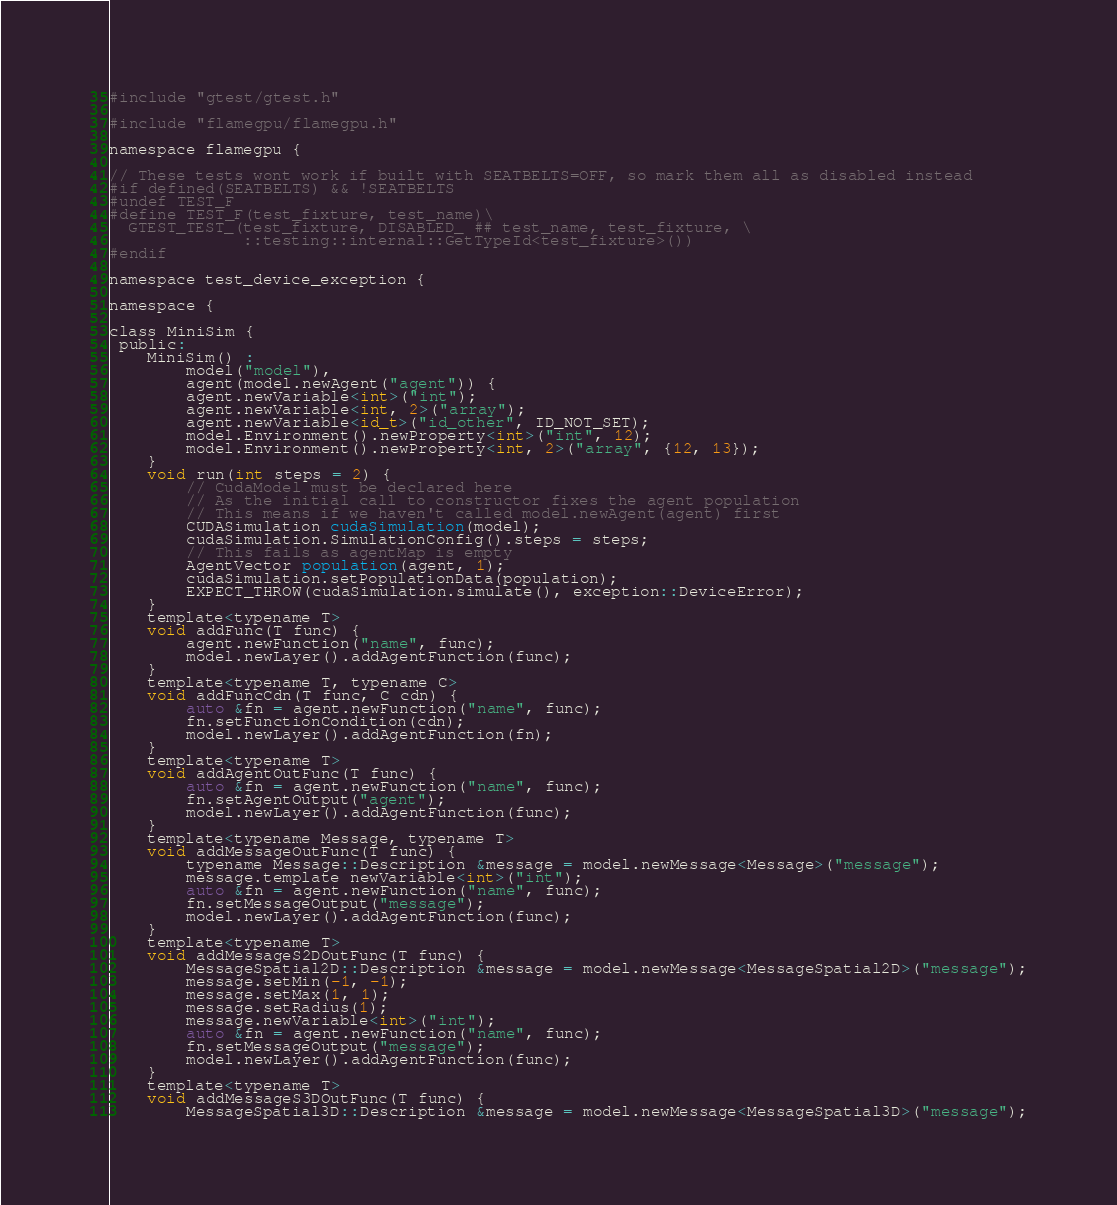Convert code to text. <code><loc_0><loc_0><loc_500><loc_500><_Cuda_>
#include "gtest/gtest.h"

#include "flamegpu/flamegpu.h"

namespace flamegpu {

// These tests wont work if built with SEATBELTS=OFF, so mark them all as disabled instead
#if defined(SEATBELTS) && !SEATBELTS
#undef TEST_F
#define TEST_F(test_fixture, test_name)\
  GTEST_TEST_(test_fixture, DISABLED_ ## test_name, test_fixture, \
              ::testing::internal::GetTypeId<test_fixture>())
#endif

namespace test_device_exception {

namespace {

class MiniSim {
 public:
    MiniSim() :
        model("model"),
        agent(model.newAgent("agent")) {
        agent.newVariable<int>("int");
        agent.newVariable<int, 2>("array");
        agent.newVariable<id_t>("id_other", ID_NOT_SET);
        model.Environment().newProperty<int>("int", 12);
        model.Environment().newProperty<int, 2>("array", {12, 13});
    }
    void run(int steps = 2) {
        // CudaModel must be declared here
        // As the initial call to constructor fixes the agent population
        // This means if we haven't called model.newAgent(agent) first
        CUDASimulation cudaSimulation(model);
        cudaSimulation.SimulationConfig().steps = steps;
        // This fails as agentMap is empty
        AgentVector population(agent, 1);
        cudaSimulation.setPopulationData(population);
        EXPECT_THROW(cudaSimulation.simulate(), exception::DeviceError);
    }
    template<typename T>
    void addFunc(T func) {
        agent.newFunction("name", func);
        model.newLayer().addAgentFunction(func);
    }
    template<typename T, typename C>
    void addFuncCdn(T func, C cdn) {
        auto &fn = agent.newFunction("name", func);
        fn.setFunctionCondition(cdn);
        model.newLayer().addAgentFunction(fn);
    }
    template<typename T>
    void addAgentOutFunc(T func) {
        auto &fn = agent.newFunction("name", func);
        fn.setAgentOutput("agent");
        model.newLayer().addAgentFunction(func);
    }
    template<typename Message, typename T>
    void addMessageOutFunc(T func) {
        typename Message::Description &message = model.newMessage<Message>("message");
        message.template newVariable<int>("int");
        auto &fn = agent.newFunction("name", func);
        fn.setMessageOutput("message");
        model.newLayer().addAgentFunction(func);
    }
    template<typename T>
    void addMessageS2DOutFunc(T func) {
        MessageSpatial2D::Description &message = model.newMessage<MessageSpatial2D>("message");
        message.setMin(-1, -1);
        message.setMax(1, 1);
        message.setRadius(1);
        message.newVariable<int>("int");
        auto &fn = agent.newFunction("name", func);
        fn.setMessageOutput("message");
        model.newLayer().addAgentFunction(func);
    }
    template<typename T>
    void addMessageS3DOutFunc(T func) {
        MessageSpatial3D::Description &message = model.newMessage<MessageSpatial3D>("message");</code> 